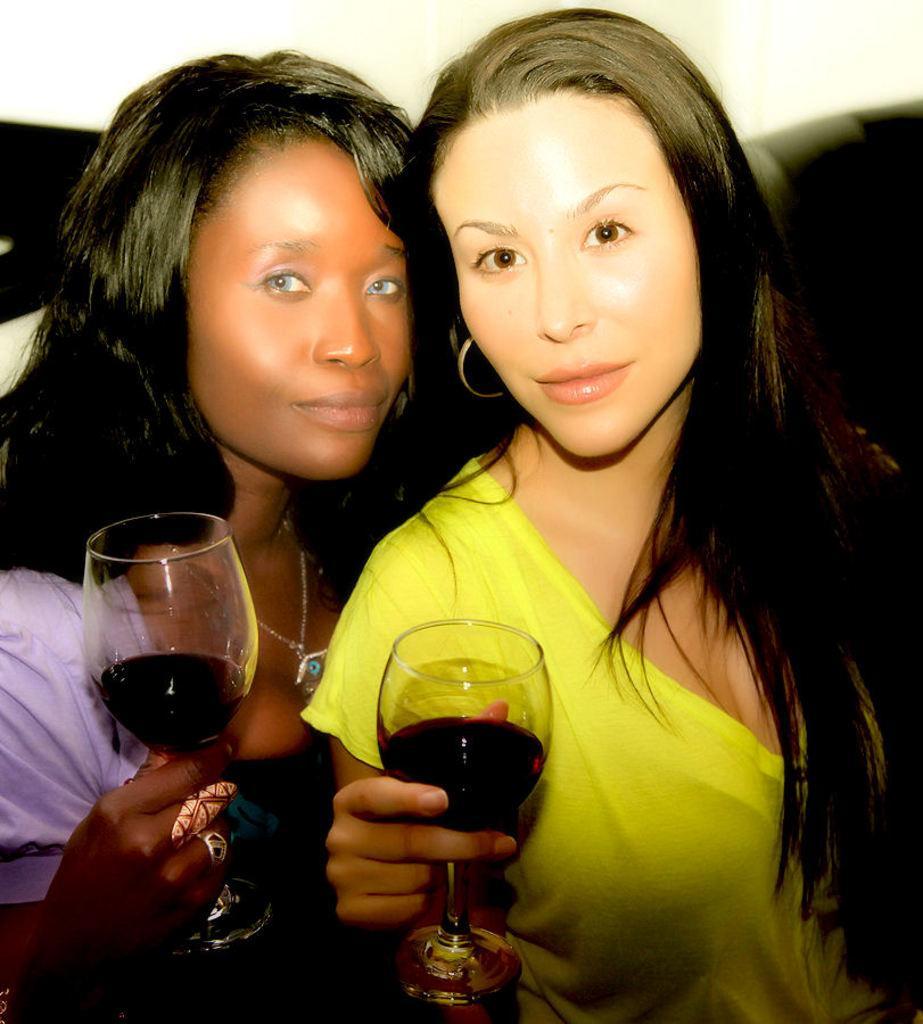In one or two sentences, can you explain what this image depicts? In the picture we can see two women are holding a wine glasses, one woman is wearing a blue T-shirt and one is wearing a yellow T-shirt. In the background we can see a wall. 